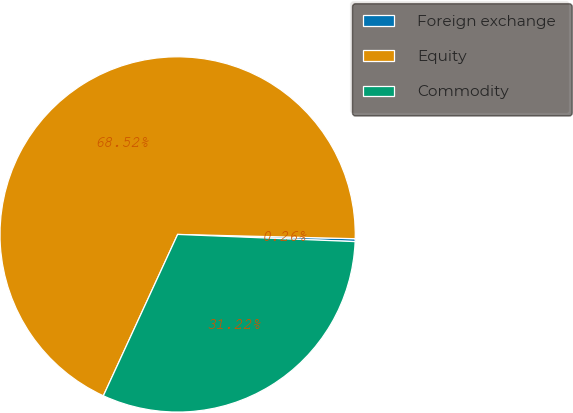<chart> <loc_0><loc_0><loc_500><loc_500><pie_chart><fcel>Foreign exchange<fcel>Equity<fcel>Commodity<nl><fcel>0.26%<fcel>68.51%<fcel>31.22%<nl></chart> 